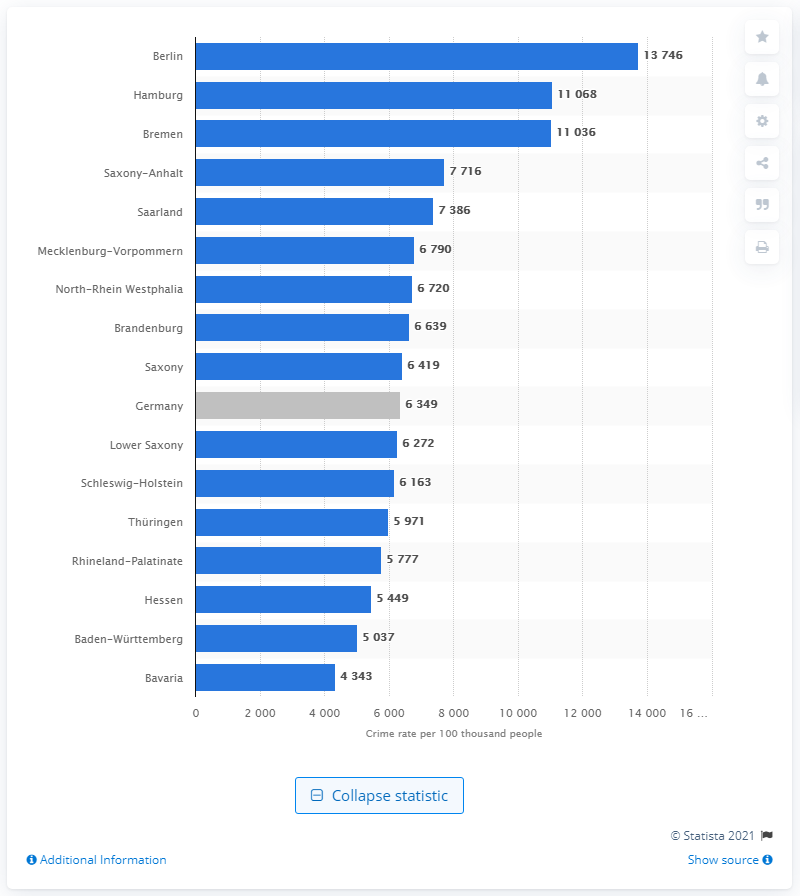List a handful of essential elements in this visual. According to the data, Saxony-Anhalt was the federal state with the highest crime rate among all the federal states in Germany. Bavaria had the lowest crime rate among the federal states in Germany in 2019. 